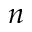<formula> <loc_0><loc_0><loc_500><loc_500>n</formula> 